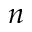<formula> <loc_0><loc_0><loc_500><loc_500>n</formula> 